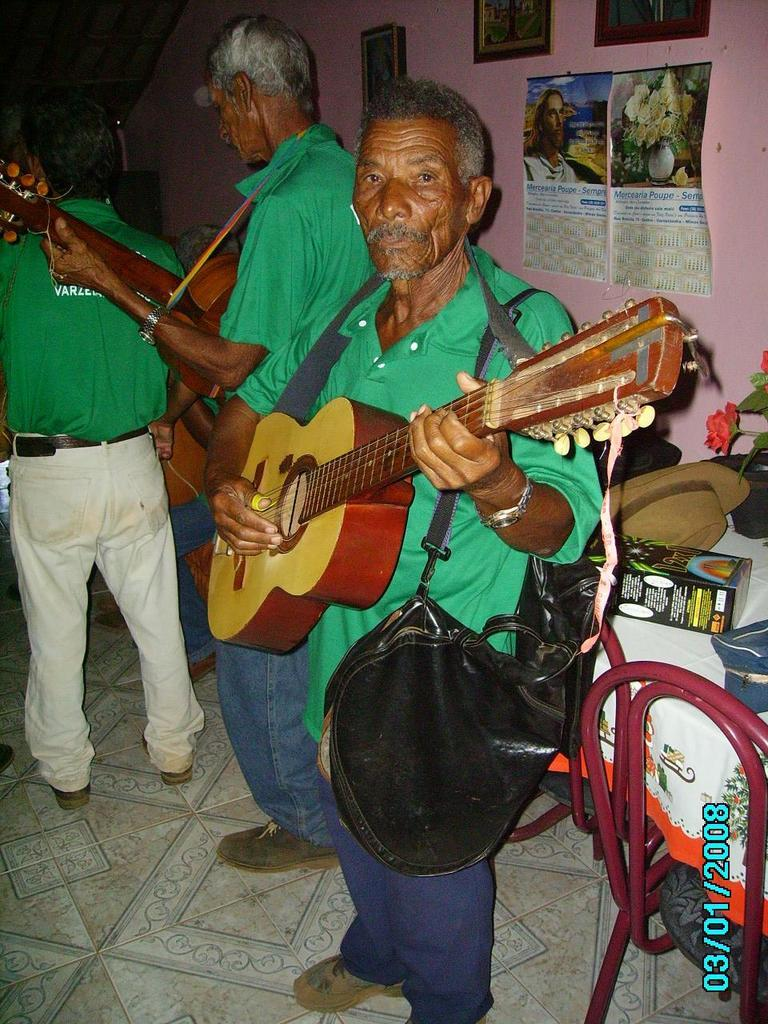What are the people in the image doing? The people in the image are standing and holding musical instruments. Can you describe any additional items the people are carrying? One person is carrying a bag. What objects can be seen on the table in the image? A cap and a box are present on the table. What is the purpose of the table in the image? The table might be used for holding or displaying the items mentioned, such as the cap and box. Can you tell me how many times the people in the image kick a railway in the image? There is no railway present in the image, and therefore no kicking can be observed. 